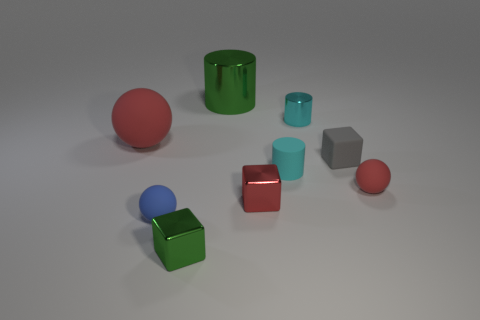What is the shape of the metal object that is the same color as the matte cylinder?
Your answer should be very brief. Cylinder. What number of other things are there of the same material as the gray object
Provide a succinct answer. 4. Are there any other things that have the same shape as the large matte thing?
Give a very brief answer. Yes. What is the color of the tiny metallic thing that is behind the cube to the right of the metallic cube that is to the right of the green metallic cylinder?
Make the answer very short. Cyan. There is a shiny object that is both on the left side of the cyan metallic cylinder and behind the tiny cyan matte cylinder; what shape is it?
Keep it short and to the point. Cylinder. Are there any other things that are the same size as the blue rubber object?
Make the answer very short. Yes. What color is the tiny sphere that is behind the blue ball on the left side of the small red shiny object?
Keep it short and to the point. Red. There is a rubber thing on the left side of the rubber object that is in front of the shiny cube to the right of the large shiny object; what is its shape?
Your answer should be compact. Sphere. There is a object that is both on the left side of the big green cylinder and on the right side of the tiny blue sphere; what is its size?
Your response must be concise. Small. How many tiny matte cylinders are the same color as the small shiny cylinder?
Keep it short and to the point. 1. 